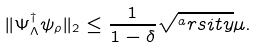<formula> <loc_0><loc_0><loc_500><loc_500>\| \Psi _ { \Lambda } ^ { \dagger } \psi _ { \rho } \| _ { 2 } \leq \frac { 1 } { 1 - \delta } \sqrt { ^ { a } r s i t y } \mu .</formula> 